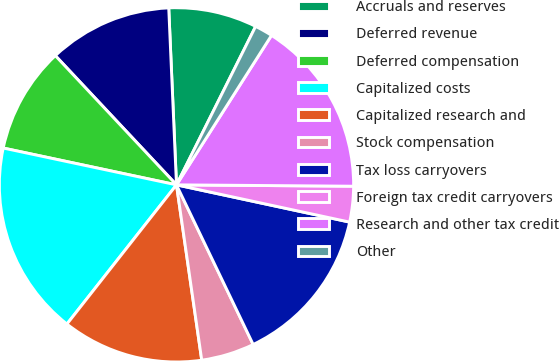<chart> <loc_0><loc_0><loc_500><loc_500><pie_chart><fcel>Accruals and reserves<fcel>Deferred revenue<fcel>Deferred compensation<fcel>Capitalized costs<fcel>Capitalized research and<fcel>Stock compensation<fcel>Tax loss carryovers<fcel>Foreign tax credit carryovers<fcel>Research and other tax credit<fcel>Other<nl><fcel>8.07%<fcel>11.29%<fcel>9.68%<fcel>17.72%<fcel>12.89%<fcel>4.85%<fcel>14.5%<fcel>3.25%<fcel>16.11%<fcel>1.64%<nl></chart> 